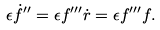<formula> <loc_0><loc_0><loc_500><loc_500>\epsilon \dot { f } ^ { \prime \prime } = \epsilon f ^ { \prime \prime \prime } \dot { r } = \epsilon f ^ { \prime \prime \prime } f .</formula> 